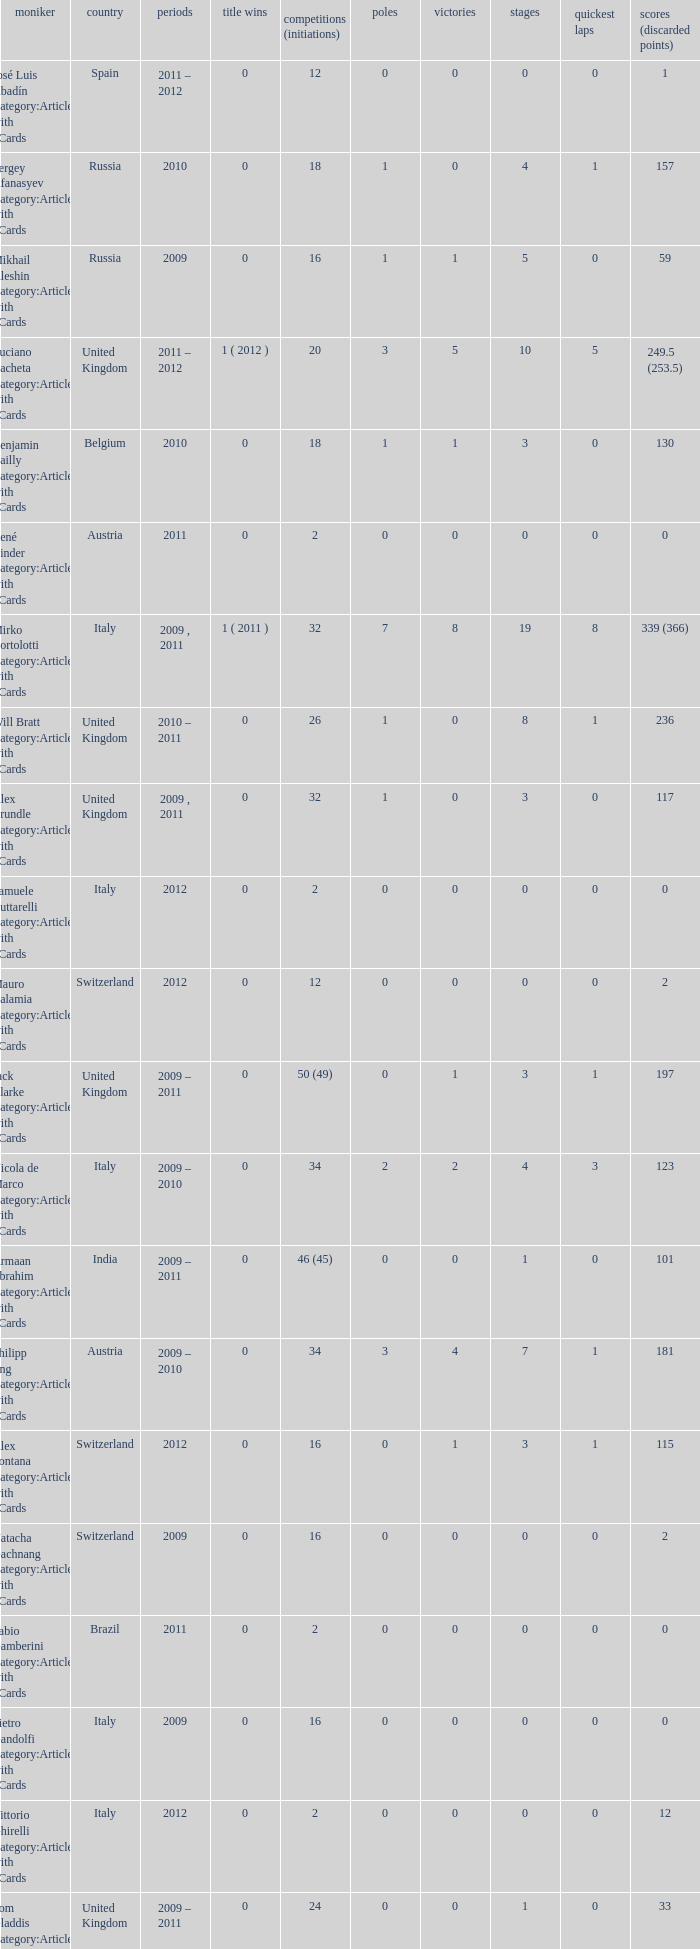When did they win 7 races? 2009.0. 